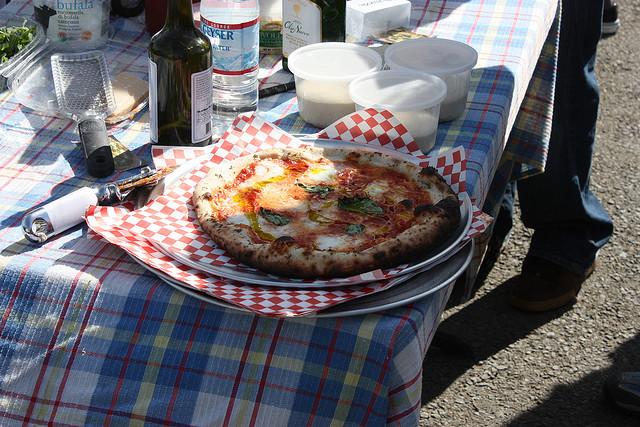What food is on the plate?
Concise answer only. Pizza. What is the white stuff in the bowls?
Be succinct. Cheese. Is there a cheese grater on the table?
Answer briefly. Yes. 